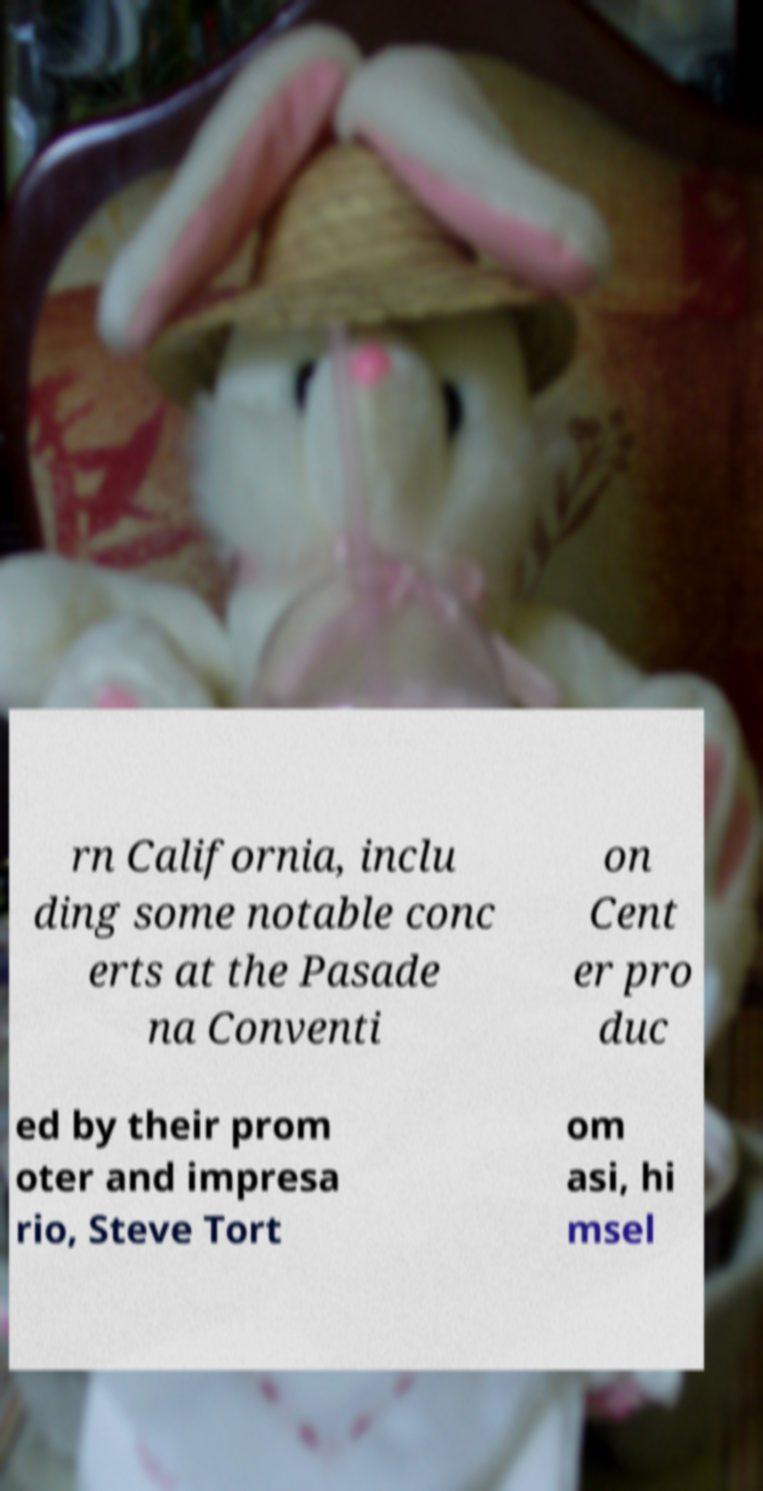I need the written content from this picture converted into text. Can you do that? rn California, inclu ding some notable conc erts at the Pasade na Conventi on Cent er pro duc ed by their prom oter and impresa rio, Steve Tort om asi, hi msel 